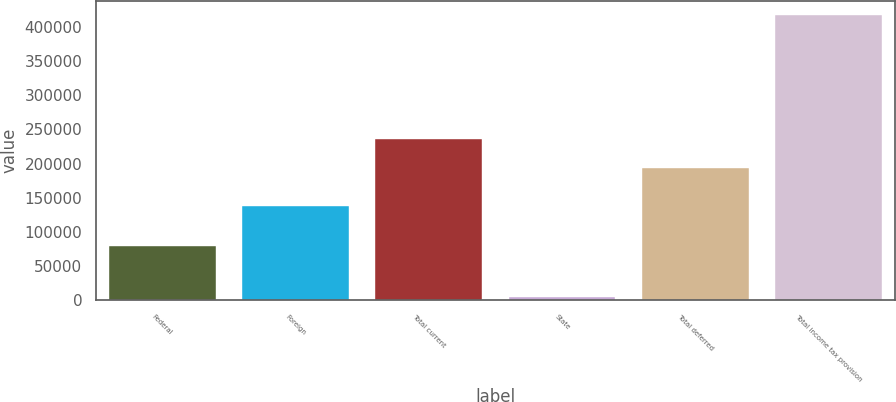Convert chart to OTSL. <chart><loc_0><loc_0><loc_500><loc_500><bar_chart><fcel>Federal<fcel>Foreign<fcel>Total current<fcel>State<fcel>Total deferred<fcel>Total income tax provision<nl><fcel>79680<fcel>138271<fcel>235576<fcel>4641<fcel>194261<fcel>417789<nl></chart> 